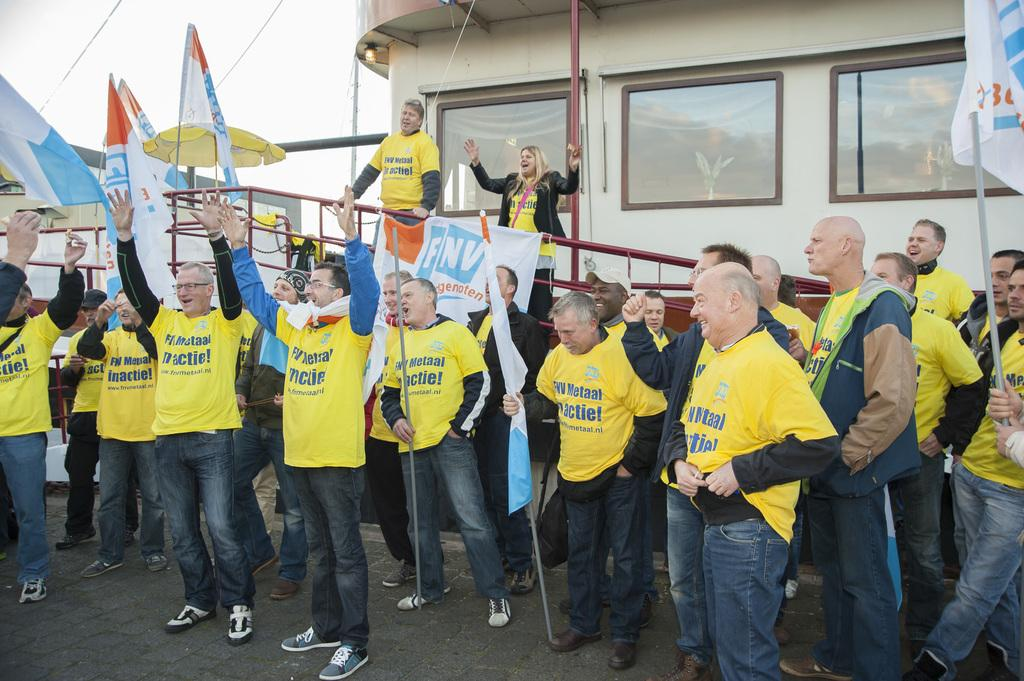What are the people in the image doing? The people in the image are standing on the ground and holding flags. What else can be seen in the image besides the people? There is a banner, a ship, a fence, a pole, a rod, and the sky visible in the image. What type of bait is being used by the people in the image? There is no mention of bait or fishing in the image, so it cannot be determined from the image. 